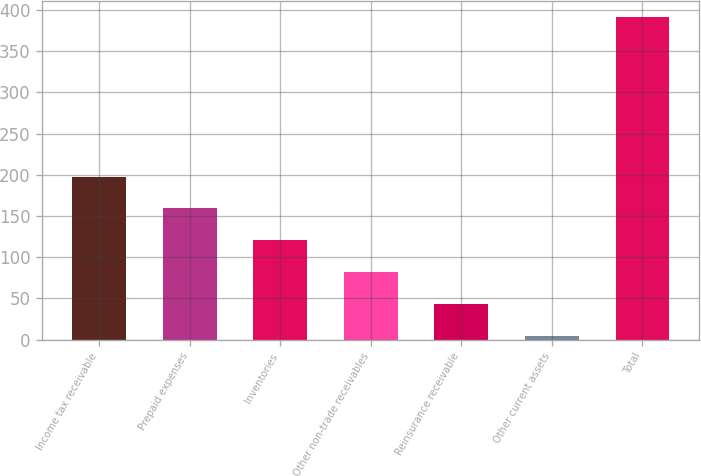<chart> <loc_0><loc_0><loc_500><loc_500><bar_chart><fcel>Income tax receivable<fcel>Prepaid expenses<fcel>Inventories<fcel>Other non-trade receivables<fcel>Reinsurance receivable<fcel>Other current assets<fcel>Total<nl><fcel>197.85<fcel>159.18<fcel>120.51<fcel>81.84<fcel>43.17<fcel>4.5<fcel>391.2<nl></chart> 